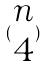<formula> <loc_0><loc_0><loc_500><loc_500>( \begin{matrix} n \\ 4 \end{matrix} )</formula> 